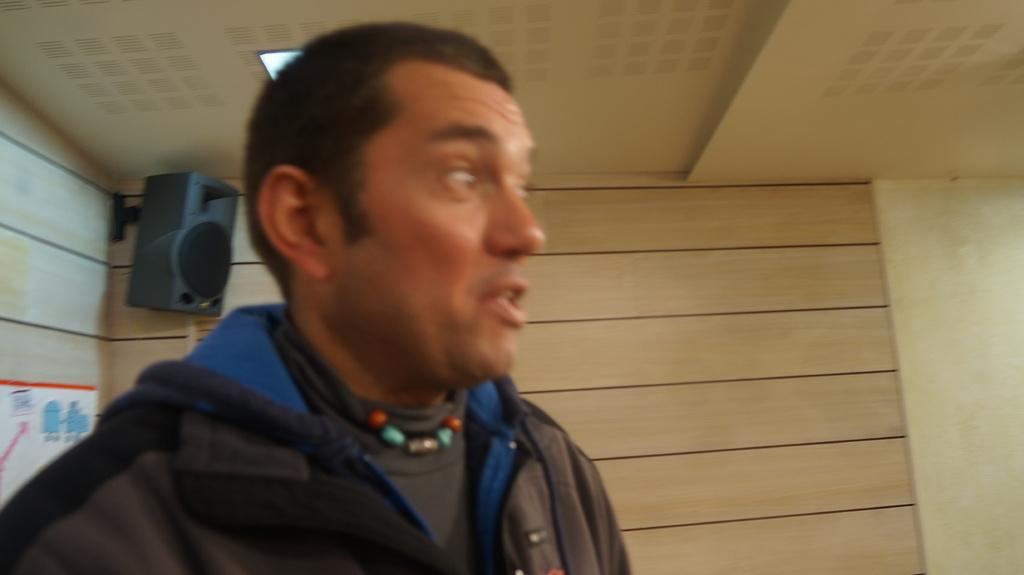Who is present in the image? There is a man in the image. What can be seen on the wall in the image? There is a board with a picture on the wall in the image, as well as a speaker. What type of structure is visible in the image? There is a roof in the image, which suggests it is an indoor space. What is the source of light in the image? There is a ceiling light in the image. Can you see any friends or plants on the coast in the image? There is no coast, friends, or plants present in the image. 